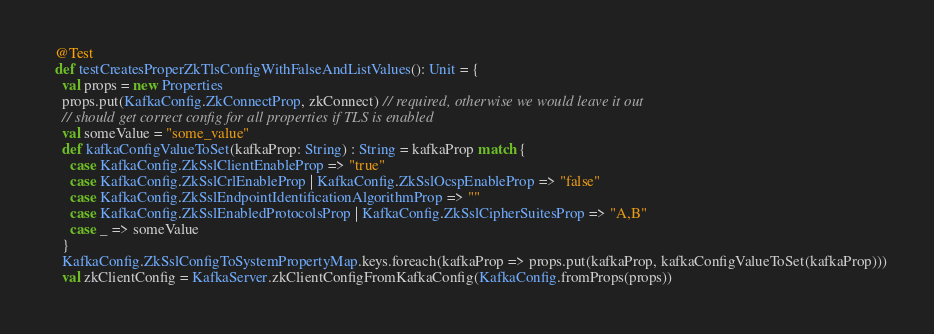<code> <loc_0><loc_0><loc_500><loc_500><_Scala_>  @Test
  def testCreatesProperZkTlsConfigWithFalseAndListValues(): Unit = {
    val props = new Properties
    props.put(KafkaConfig.ZkConnectProp, zkConnect) // required, otherwise we would leave it out
    // should get correct config for all properties if TLS is enabled
    val someValue = "some_value"
    def kafkaConfigValueToSet(kafkaProp: String) : String = kafkaProp match {
      case KafkaConfig.ZkSslClientEnableProp => "true"
      case KafkaConfig.ZkSslCrlEnableProp | KafkaConfig.ZkSslOcspEnableProp => "false"
      case KafkaConfig.ZkSslEndpointIdentificationAlgorithmProp => ""
      case KafkaConfig.ZkSslEnabledProtocolsProp | KafkaConfig.ZkSslCipherSuitesProp => "A,B"
      case _ => someValue
    }
    KafkaConfig.ZkSslConfigToSystemPropertyMap.keys.foreach(kafkaProp => props.put(kafkaProp, kafkaConfigValueToSet(kafkaProp)))
    val zkClientConfig = KafkaServer.zkClientConfigFromKafkaConfig(KafkaConfig.fromProps(props))</code> 